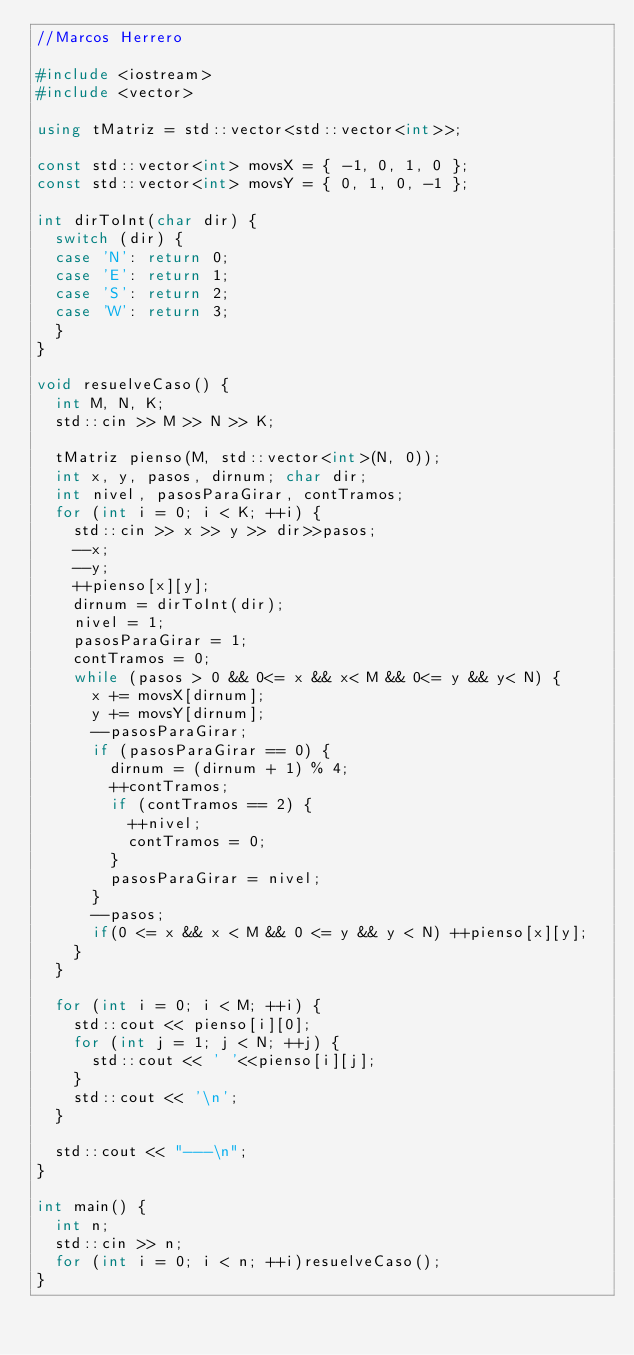<code> <loc_0><loc_0><loc_500><loc_500><_C++_>//Marcos Herrero

#include <iostream>
#include <vector>

using tMatriz = std::vector<std::vector<int>>;

const std::vector<int> movsX = { -1, 0, 1, 0 };
const std::vector<int> movsY = { 0, 1, 0, -1 };

int dirToInt(char dir) {
	switch (dir) {
	case 'N': return 0;
	case 'E': return 1;
	case 'S': return 2;
	case 'W': return 3;
	}
}

void resuelveCaso() {
	int M, N, K;
	std::cin >> M >> N >> K;

	tMatriz pienso(M, std::vector<int>(N, 0));
	int x, y, pasos, dirnum; char dir;
	int nivel, pasosParaGirar, contTramos;
	for (int i = 0; i < K; ++i) {
		std::cin >> x >> y >> dir>>pasos;
		--x;
		--y;
		++pienso[x][y];
		dirnum = dirToInt(dir);
		nivel = 1;
		pasosParaGirar = 1;
		contTramos = 0;
		while (pasos > 0 && 0<= x && x< M && 0<= y && y< N) {
			x += movsX[dirnum];
			y += movsY[dirnum];
			--pasosParaGirar;
			if (pasosParaGirar == 0) {
				dirnum = (dirnum + 1) % 4;
				++contTramos;
				if (contTramos == 2) {
					++nivel;
					contTramos = 0;
				}
				pasosParaGirar = nivel;
			}
			--pasos;
			if(0 <= x && x < M && 0 <= y && y < N) ++pienso[x][y];
		}
	}

	for (int i = 0; i < M; ++i) {
		std::cout << pienso[i][0];
		for (int j = 1; j < N; ++j) {
			std::cout << ' '<<pienso[i][j];
		}
		std::cout << '\n';
	}

	std::cout << "---\n";
}

int main() {
	int n;
	std::cin >> n;
	for (int i = 0; i < n; ++i)resuelveCaso();
}</code> 